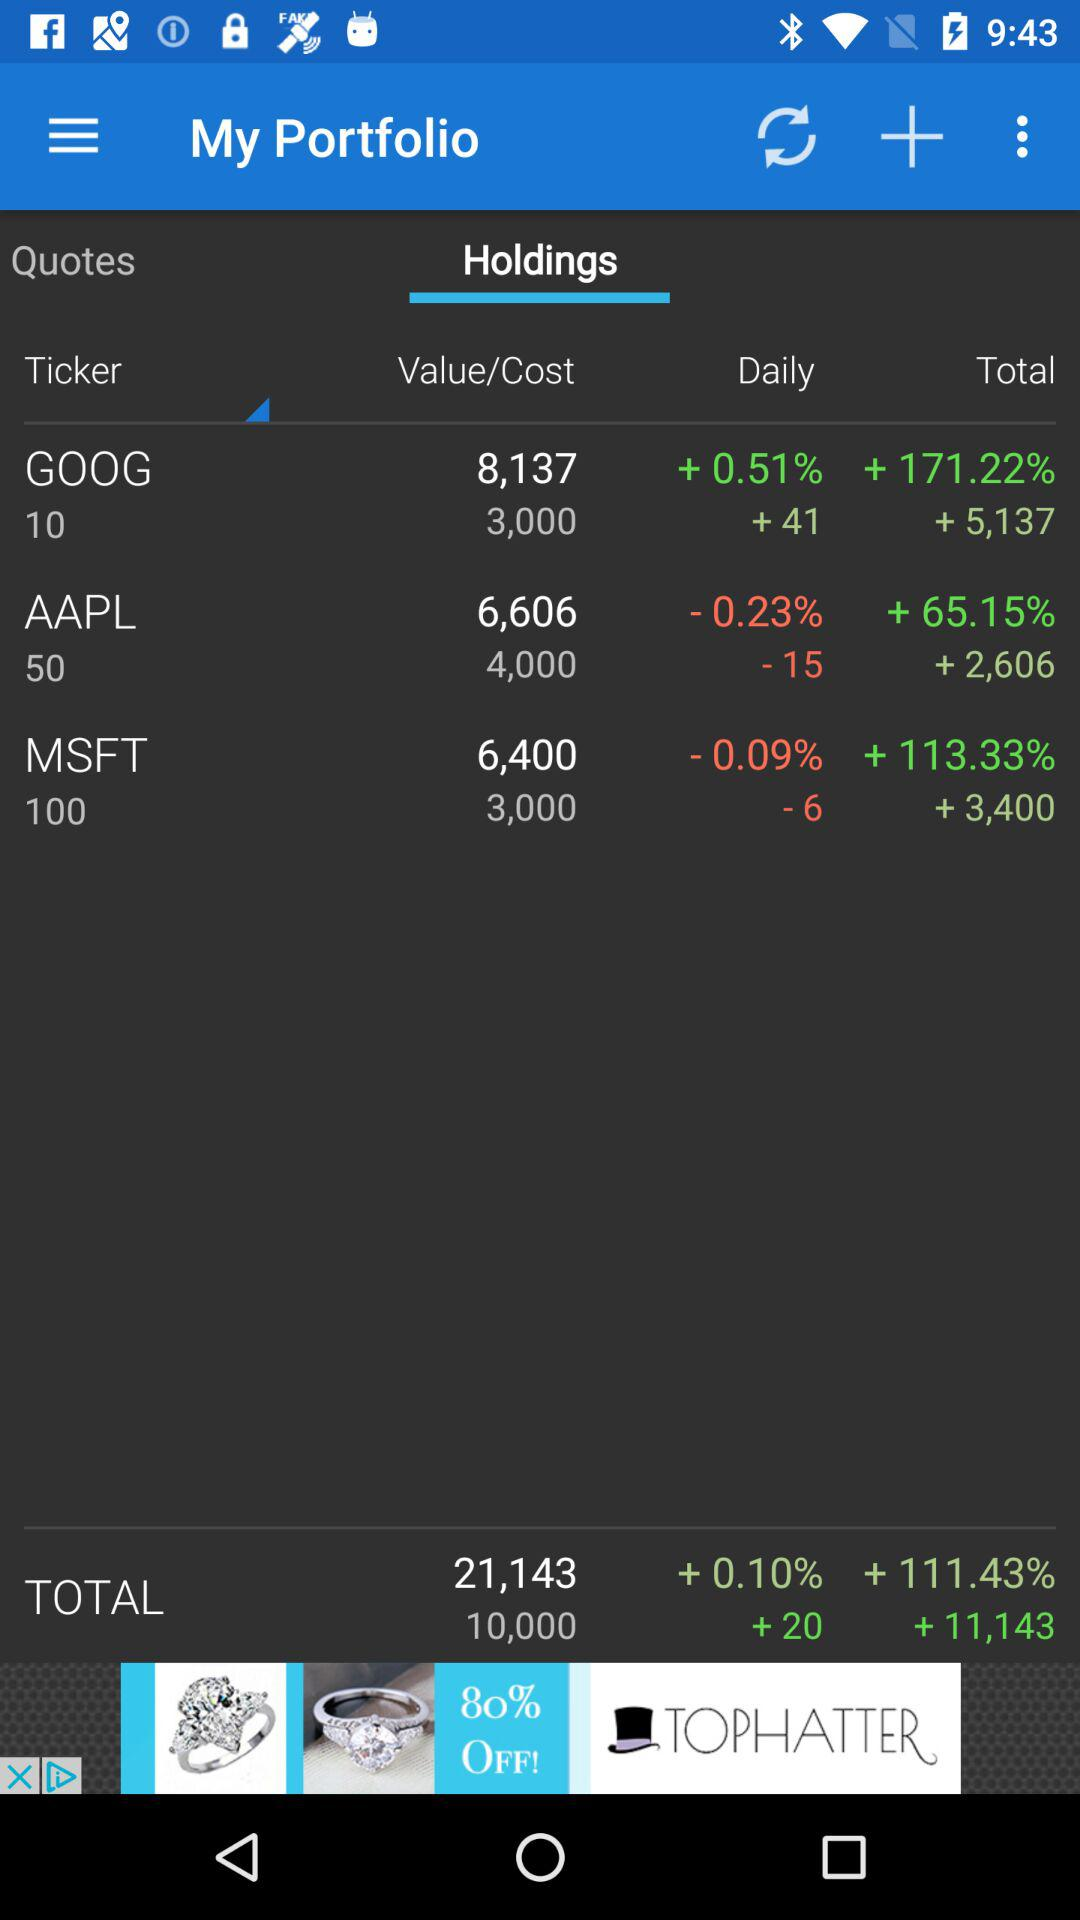What stock has a value of 6400? The stock that has a value of 6400 is MSFT. 